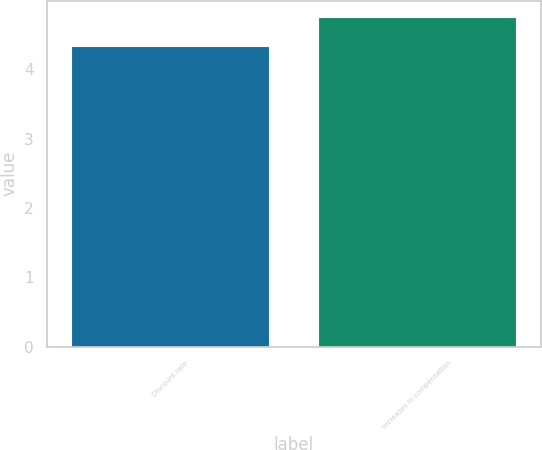Convert chart to OTSL. <chart><loc_0><loc_0><loc_500><loc_500><bar_chart><fcel>Discount rate<fcel>Increases in compensation<nl><fcel>4.33<fcel>4.75<nl></chart> 